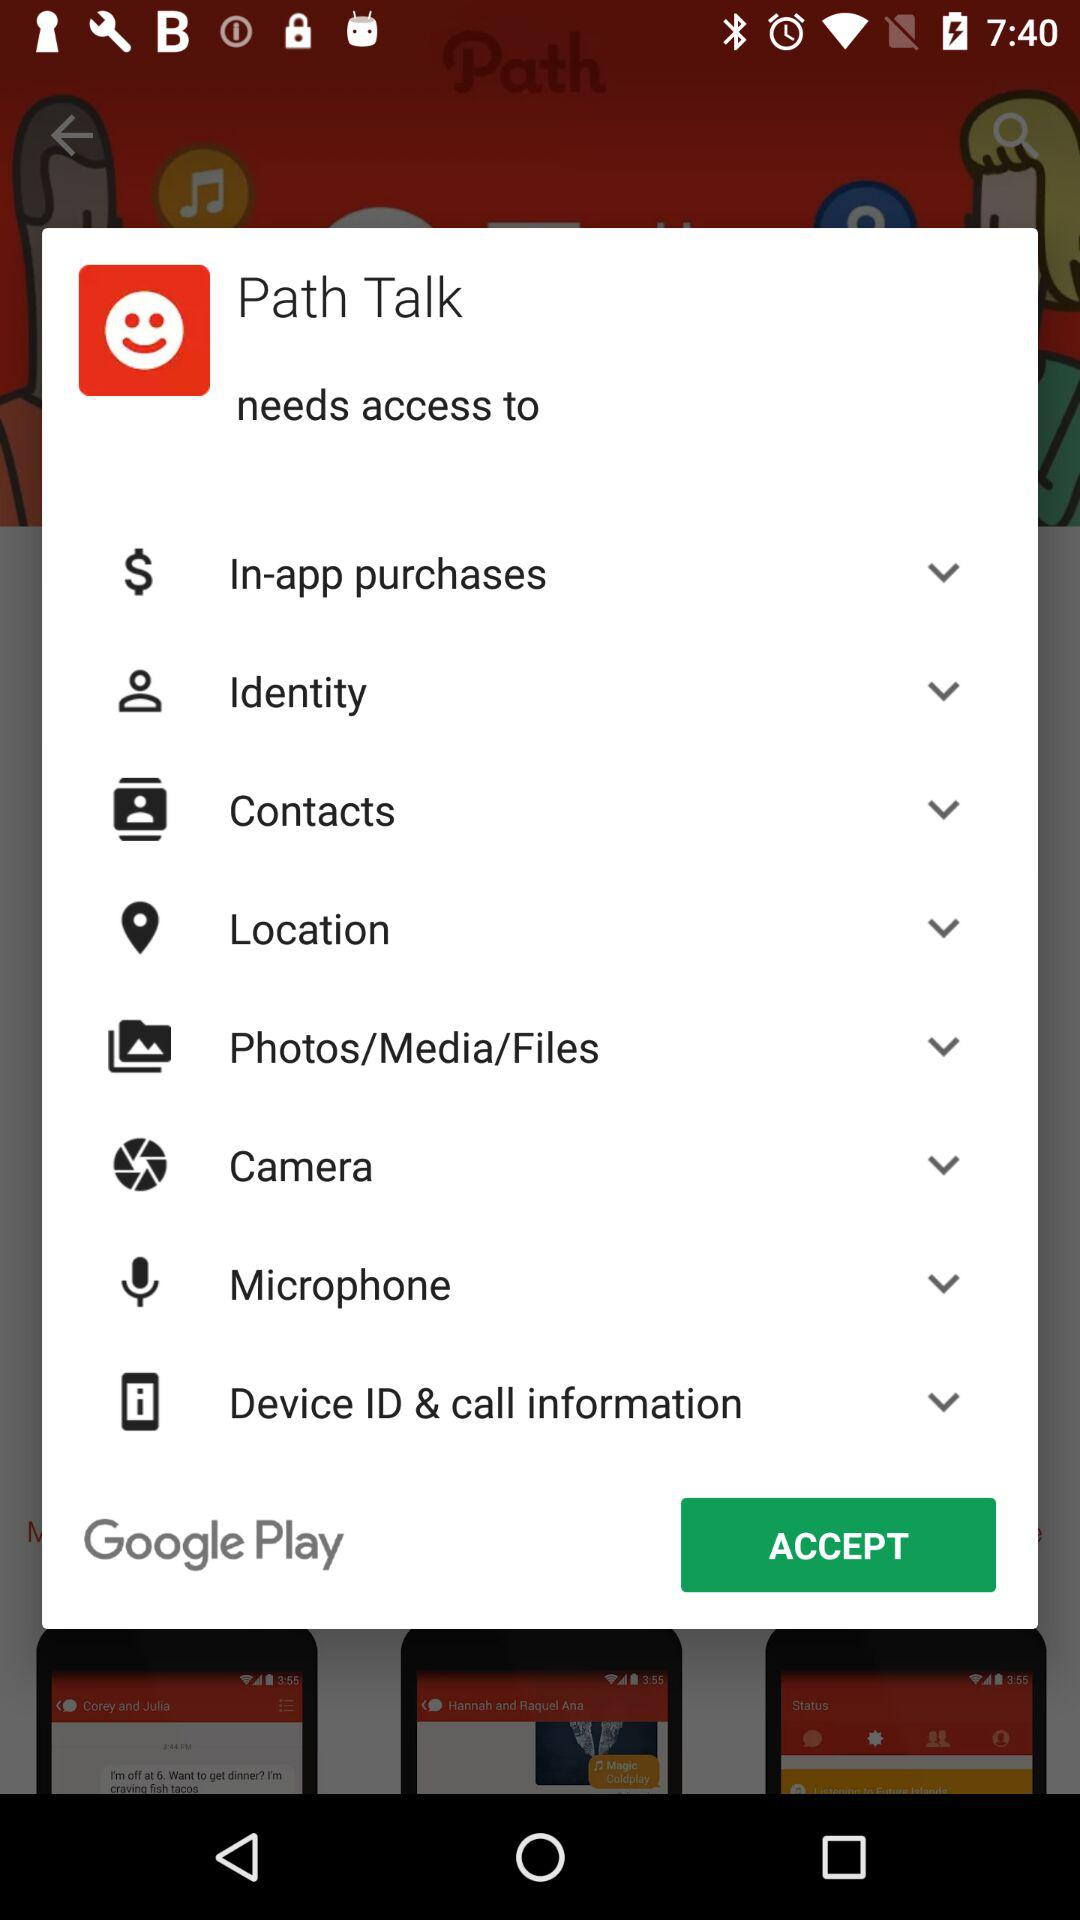What is the application name? The application name is "Path Talk". 